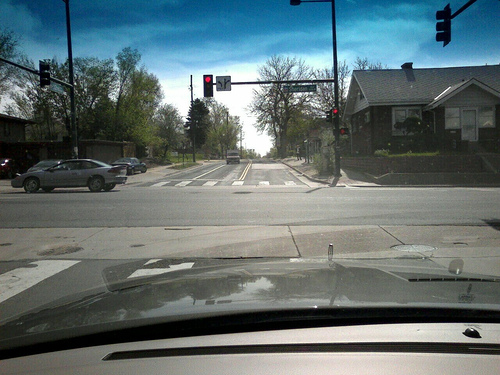How many cars are in the photo? There are 2 cars visible in the photo, one to the left turning left and another one across the intersection going straight. The scene captures a typical street view with traffic lights and tree-lined sidewalks. 